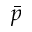<formula> <loc_0><loc_0><loc_500><loc_500>\bar { p }</formula> 